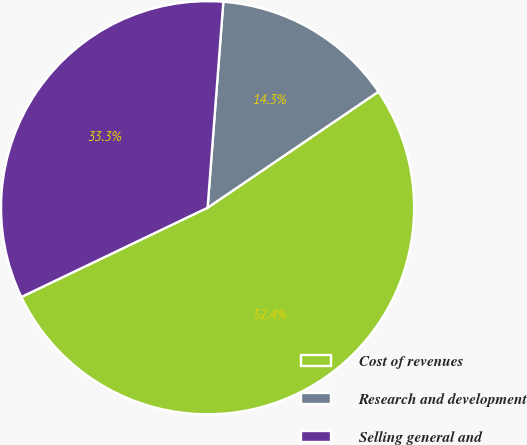Convert chart. <chart><loc_0><loc_0><loc_500><loc_500><pie_chart><fcel>Cost of revenues<fcel>Research and development<fcel>Selling general and<nl><fcel>52.38%<fcel>14.29%<fcel>33.33%<nl></chart> 